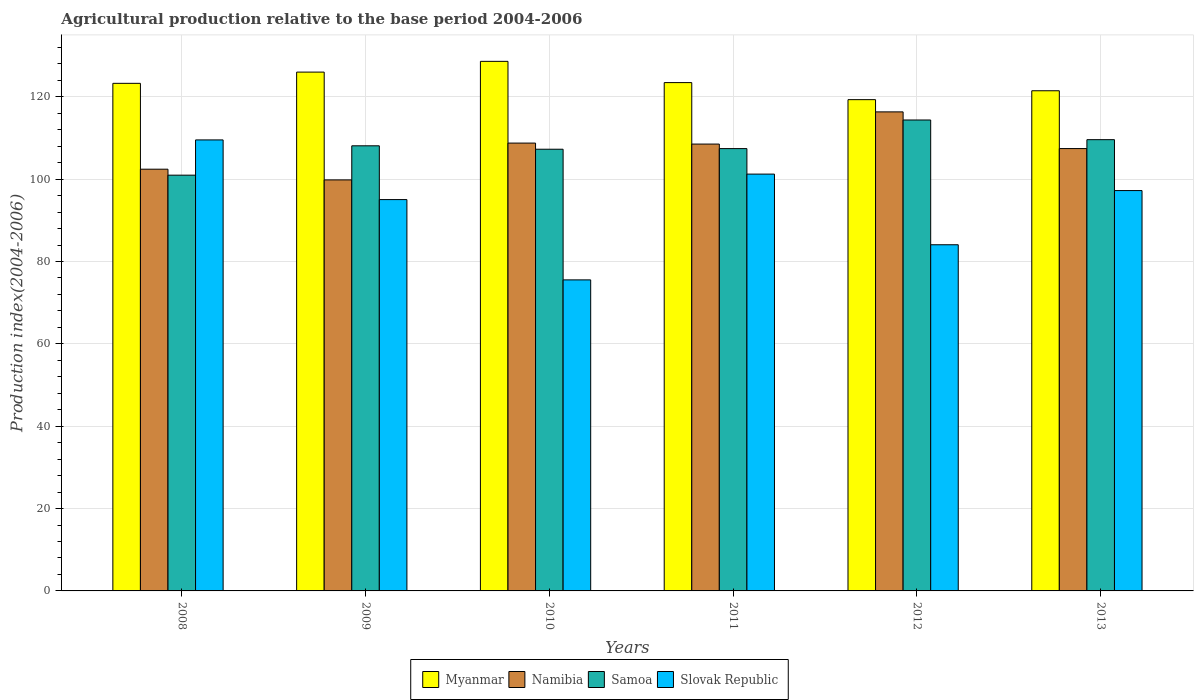How many different coloured bars are there?
Make the answer very short. 4. Are the number of bars per tick equal to the number of legend labels?
Your answer should be compact. Yes. What is the agricultural production index in Slovak Republic in 2013?
Your answer should be very brief. 97.23. Across all years, what is the maximum agricultural production index in Namibia?
Your response must be concise. 116.34. Across all years, what is the minimum agricultural production index in Samoa?
Give a very brief answer. 100.97. What is the total agricultural production index in Slovak Republic in the graph?
Make the answer very short. 562.64. What is the difference between the agricultural production index in Samoa in 2009 and that in 2012?
Offer a terse response. -6.27. What is the difference between the agricultural production index in Slovak Republic in 2008 and the agricultural production index in Samoa in 2010?
Offer a very short reply. 2.26. What is the average agricultural production index in Myanmar per year?
Give a very brief answer. 123.69. In the year 2009, what is the difference between the agricultural production index in Myanmar and agricultural production index in Namibia?
Keep it short and to the point. 26.18. What is the ratio of the agricultural production index in Slovak Republic in 2008 to that in 2013?
Your answer should be compact. 1.13. Is the agricultural production index in Myanmar in 2011 less than that in 2013?
Your answer should be compact. No. Is the difference between the agricultural production index in Myanmar in 2008 and 2011 greater than the difference between the agricultural production index in Namibia in 2008 and 2011?
Your answer should be compact. Yes. What is the difference between the highest and the second highest agricultural production index in Samoa?
Make the answer very short. 4.78. What is the difference between the highest and the lowest agricultural production index in Namibia?
Make the answer very short. 16.52. In how many years, is the agricultural production index in Samoa greater than the average agricultural production index in Samoa taken over all years?
Provide a short and direct response. 3. Is it the case that in every year, the sum of the agricultural production index in Samoa and agricultural production index in Slovak Republic is greater than the sum of agricultural production index in Myanmar and agricultural production index in Namibia?
Your answer should be compact. No. What does the 2nd bar from the left in 2008 represents?
Offer a very short reply. Namibia. What does the 2nd bar from the right in 2009 represents?
Ensure brevity in your answer.  Samoa. Is it the case that in every year, the sum of the agricultural production index in Myanmar and agricultural production index in Slovak Republic is greater than the agricultural production index in Samoa?
Offer a terse response. Yes. How many bars are there?
Offer a terse response. 24. How many years are there in the graph?
Offer a very short reply. 6. What is the difference between two consecutive major ticks on the Y-axis?
Offer a terse response. 20. Are the values on the major ticks of Y-axis written in scientific E-notation?
Keep it short and to the point. No. Where does the legend appear in the graph?
Provide a succinct answer. Bottom center. How are the legend labels stacked?
Provide a short and direct response. Horizontal. What is the title of the graph?
Provide a succinct answer. Agricultural production relative to the base period 2004-2006. Does "United States" appear as one of the legend labels in the graph?
Your response must be concise. No. What is the label or title of the Y-axis?
Your answer should be compact. Production index(2004-2006). What is the Production index(2004-2006) in Myanmar in 2008?
Keep it short and to the point. 123.27. What is the Production index(2004-2006) in Namibia in 2008?
Your answer should be very brief. 102.42. What is the Production index(2004-2006) in Samoa in 2008?
Provide a succinct answer. 100.97. What is the Production index(2004-2006) in Slovak Republic in 2008?
Your response must be concise. 109.53. What is the Production index(2004-2006) of Myanmar in 2009?
Your answer should be compact. 126. What is the Production index(2004-2006) of Namibia in 2009?
Provide a succinct answer. 99.82. What is the Production index(2004-2006) of Samoa in 2009?
Offer a terse response. 108.1. What is the Production index(2004-2006) of Slovak Republic in 2009?
Your answer should be very brief. 95.04. What is the Production index(2004-2006) of Myanmar in 2010?
Provide a succinct answer. 128.61. What is the Production index(2004-2006) of Namibia in 2010?
Offer a terse response. 108.76. What is the Production index(2004-2006) in Samoa in 2010?
Your answer should be very brief. 107.27. What is the Production index(2004-2006) in Slovak Republic in 2010?
Your response must be concise. 75.54. What is the Production index(2004-2006) of Myanmar in 2011?
Make the answer very short. 123.45. What is the Production index(2004-2006) of Namibia in 2011?
Provide a short and direct response. 108.52. What is the Production index(2004-2006) in Samoa in 2011?
Provide a succinct answer. 107.42. What is the Production index(2004-2006) of Slovak Republic in 2011?
Ensure brevity in your answer.  101.23. What is the Production index(2004-2006) in Myanmar in 2012?
Make the answer very short. 119.31. What is the Production index(2004-2006) in Namibia in 2012?
Ensure brevity in your answer.  116.34. What is the Production index(2004-2006) in Samoa in 2012?
Ensure brevity in your answer.  114.37. What is the Production index(2004-2006) of Slovak Republic in 2012?
Provide a short and direct response. 84.07. What is the Production index(2004-2006) in Myanmar in 2013?
Provide a succinct answer. 121.47. What is the Production index(2004-2006) of Namibia in 2013?
Your response must be concise. 107.43. What is the Production index(2004-2006) in Samoa in 2013?
Your answer should be compact. 109.59. What is the Production index(2004-2006) of Slovak Republic in 2013?
Your answer should be very brief. 97.23. Across all years, what is the maximum Production index(2004-2006) of Myanmar?
Give a very brief answer. 128.61. Across all years, what is the maximum Production index(2004-2006) of Namibia?
Your answer should be compact. 116.34. Across all years, what is the maximum Production index(2004-2006) of Samoa?
Your answer should be compact. 114.37. Across all years, what is the maximum Production index(2004-2006) of Slovak Republic?
Offer a very short reply. 109.53. Across all years, what is the minimum Production index(2004-2006) in Myanmar?
Your answer should be compact. 119.31. Across all years, what is the minimum Production index(2004-2006) in Namibia?
Your answer should be very brief. 99.82. Across all years, what is the minimum Production index(2004-2006) in Samoa?
Your answer should be compact. 100.97. Across all years, what is the minimum Production index(2004-2006) of Slovak Republic?
Your answer should be compact. 75.54. What is the total Production index(2004-2006) of Myanmar in the graph?
Provide a short and direct response. 742.11. What is the total Production index(2004-2006) of Namibia in the graph?
Your answer should be very brief. 643.29. What is the total Production index(2004-2006) in Samoa in the graph?
Offer a very short reply. 647.72. What is the total Production index(2004-2006) in Slovak Republic in the graph?
Give a very brief answer. 562.64. What is the difference between the Production index(2004-2006) in Myanmar in 2008 and that in 2009?
Keep it short and to the point. -2.73. What is the difference between the Production index(2004-2006) of Namibia in 2008 and that in 2009?
Your answer should be very brief. 2.6. What is the difference between the Production index(2004-2006) of Samoa in 2008 and that in 2009?
Ensure brevity in your answer.  -7.13. What is the difference between the Production index(2004-2006) of Slovak Republic in 2008 and that in 2009?
Provide a short and direct response. 14.49. What is the difference between the Production index(2004-2006) of Myanmar in 2008 and that in 2010?
Offer a terse response. -5.34. What is the difference between the Production index(2004-2006) in Namibia in 2008 and that in 2010?
Your response must be concise. -6.34. What is the difference between the Production index(2004-2006) in Samoa in 2008 and that in 2010?
Offer a very short reply. -6.3. What is the difference between the Production index(2004-2006) of Slovak Republic in 2008 and that in 2010?
Your response must be concise. 33.99. What is the difference between the Production index(2004-2006) of Myanmar in 2008 and that in 2011?
Give a very brief answer. -0.18. What is the difference between the Production index(2004-2006) of Samoa in 2008 and that in 2011?
Provide a succinct answer. -6.45. What is the difference between the Production index(2004-2006) of Slovak Republic in 2008 and that in 2011?
Provide a succinct answer. 8.3. What is the difference between the Production index(2004-2006) of Myanmar in 2008 and that in 2012?
Ensure brevity in your answer.  3.96. What is the difference between the Production index(2004-2006) of Namibia in 2008 and that in 2012?
Your response must be concise. -13.92. What is the difference between the Production index(2004-2006) in Samoa in 2008 and that in 2012?
Ensure brevity in your answer.  -13.4. What is the difference between the Production index(2004-2006) of Slovak Republic in 2008 and that in 2012?
Ensure brevity in your answer.  25.46. What is the difference between the Production index(2004-2006) of Namibia in 2008 and that in 2013?
Offer a very short reply. -5.01. What is the difference between the Production index(2004-2006) in Samoa in 2008 and that in 2013?
Give a very brief answer. -8.62. What is the difference between the Production index(2004-2006) in Myanmar in 2009 and that in 2010?
Your response must be concise. -2.61. What is the difference between the Production index(2004-2006) in Namibia in 2009 and that in 2010?
Make the answer very short. -8.94. What is the difference between the Production index(2004-2006) in Samoa in 2009 and that in 2010?
Provide a short and direct response. 0.83. What is the difference between the Production index(2004-2006) of Slovak Republic in 2009 and that in 2010?
Provide a succinct answer. 19.5. What is the difference between the Production index(2004-2006) of Myanmar in 2009 and that in 2011?
Make the answer very short. 2.55. What is the difference between the Production index(2004-2006) in Namibia in 2009 and that in 2011?
Offer a terse response. -8.7. What is the difference between the Production index(2004-2006) in Samoa in 2009 and that in 2011?
Make the answer very short. 0.68. What is the difference between the Production index(2004-2006) in Slovak Republic in 2009 and that in 2011?
Make the answer very short. -6.19. What is the difference between the Production index(2004-2006) of Myanmar in 2009 and that in 2012?
Give a very brief answer. 6.69. What is the difference between the Production index(2004-2006) in Namibia in 2009 and that in 2012?
Your answer should be compact. -16.52. What is the difference between the Production index(2004-2006) in Samoa in 2009 and that in 2012?
Offer a very short reply. -6.27. What is the difference between the Production index(2004-2006) of Slovak Republic in 2009 and that in 2012?
Give a very brief answer. 10.97. What is the difference between the Production index(2004-2006) in Myanmar in 2009 and that in 2013?
Keep it short and to the point. 4.53. What is the difference between the Production index(2004-2006) of Namibia in 2009 and that in 2013?
Make the answer very short. -7.61. What is the difference between the Production index(2004-2006) in Samoa in 2009 and that in 2013?
Offer a terse response. -1.49. What is the difference between the Production index(2004-2006) in Slovak Republic in 2009 and that in 2013?
Keep it short and to the point. -2.19. What is the difference between the Production index(2004-2006) of Myanmar in 2010 and that in 2011?
Your answer should be very brief. 5.16. What is the difference between the Production index(2004-2006) of Namibia in 2010 and that in 2011?
Your answer should be very brief. 0.24. What is the difference between the Production index(2004-2006) of Samoa in 2010 and that in 2011?
Ensure brevity in your answer.  -0.15. What is the difference between the Production index(2004-2006) of Slovak Republic in 2010 and that in 2011?
Ensure brevity in your answer.  -25.69. What is the difference between the Production index(2004-2006) in Myanmar in 2010 and that in 2012?
Provide a succinct answer. 9.3. What is the difference between the Production index(2004-2006) in Namibia in 2010 and that in 2012?
Provide a succinct answer. -7.58. What is the difference between the Production index(2004-2006) of Samoa in 2010 and that in 2012?
Provide a short and direct response. -7.1. What is the difference between the Production index(2004-2006) of Slovak Republic in 2010 and that in 2012?
Your answer should be compact. -8.53. What is the difference between the Production index(2004-2006) of Myanmar in 2010 and that in 2013?
Your response must be concise. 7.14. What is the difference between the Production index(2004-2006) of Namibia in 2010 and that in 2013?
Offer a terse response. 1.33. What is the difference between the Production index(2004-2006) of Samoa in 2010 and that in 2013?
Offer a very short reply. -2.32. What is the difference between the Production index(2004-2006) of Slovak Republic in 2010 and that in 2013?
Provide a succinct answer. -21.69. What is the difference between the Production index(2004-2006) of Myanmar in 2011 and that in 2012?
Ensure brevity in your answer.  4.14. What is the difference between the Production index(2004-2006) of Namibia in 2011 and that in 2012?
Your response must be concise. -7.82. What is the difference between the Production index(2004-2006) in Samoa in 2011 and that in 2012?
Ensure brevity in your answer.  -6.95. What is the difference between the Production index(2004-2006) of Slovak Republic in 2011 and that in 2012?
Offer a very short reply. 17.16. What is the difference between the Production index(2004-2006) in Myanmar in 2011 and that in 2013?
Your answer should be very brief. 1.98. What is the difference between the Production index(2004-2006) in Namibia in 2011 and that in 2013?
Your response must be concise. 1.09. What is the difference between the Production index(2004-2006) of Samoa in 2011 and that in 2013?
Provide a short and direct response. -2.17. What is the difference between the Production index(2004-2006) of Slovak Republic in 2011 and that in 2013?
Provide a short and direct response. 4. What is the difference between the Production index(2004-2006) of Myanmar in 2012 and that in 2013?
Offer a terse response. -2.16. What is the difference between the Production index(2004-2006) in Namibia in 2012 and that in 2013?
Provide a succinct answer. 8.91. What is the difference between the Production index(2004-2006) of Samoa in 2012 and that in 2013?
Ensure brevity in your answer.  4.78. What is the difference between the Production index(2004-2006) of Slovak Republic in 2012 and that in 2013?
Give a very brief answer. -13.16. What is the difference between the Production index(2004-2006) of Myanmar in 2008 and the Production index(2004-2006) of Namibia in 2009?
Provide a short and direct response. 23.45. What is the difference between the Production index(2004-2006) in Myanmar in 2008 and the Production index(2004-2006) in Samoa in 2009?
Your response must be concise. 15.17. What is the difference between the Production index(2004-2006) of Myanmar in 2008 and the Production index(2004-2006) of Slovak Republic in 2009?
Provide a succinct answer. 28.23. What is the difference between the Production index(2004-2006) in Namibia in 2008 and the Production index(2004-2006) in Samoa in 2009?
Offer a terse response. -5.68. What is the difference between the Production index(2004-2006) of Namibia in 2008 and the Production index(2004-2006) of Slovak Republic in 2009?
Your response must be concise. 7.38. What is the difference between the Production index(2004-2006) in Samoa in 2008 and the Production index(2004-2006) in Slovak Republic in 2009?
Make the answer very short. 5.93. What is the difference between the Production index(2004-2006) in Myanmar in 2008 and the Production index(2004-2006) in Namibia in 2010?
Offer a terse response. 14.51. What is the difference between the Production index(2004-2006) in Myanmar in 2008 and the Production index(2004-2006) in Slovak Republic in 2010?
Your answer should be compact. 47.73. What is the difference between the Production index(2004-2006) of Namibia in 2008 and the Production index(2004-2006) of Samoa in 2010?
Give a very brief answer. -4.85. What is the difference between the Production index(2004-2006) of Namibia in 2008 and the Production index(2004-2006) of Slovak Republic in 2010?
Make the answer very short. 26.88. What is the difference between the Production index(2004-2006) in Samoa in 2008 and the Production index(2004-2006) in Slovak Republic in 2010?
Give a very brief answer. 25.43. What is the difference between the Production index(2004-2006) in Myanmar in 2008 and the Production index(2004-2006) in Namibia in 2011?
Your response must be concise. 14.75. What is the difference between the Production index(2004-2006) in Myanmar in 2008 and the Production index(2004-2006) in Samoa in 2011?
Ensure brevity in your answer.  15.85. What is the difference between the Production index(2004-2006) in Myanmar in 2008 and the Production index(2004-2006) in Slovak Republic in 2011?
Keep it short and to the point. 22.04. What is the difference between the Production index(2004-2006) in Namibia in 2008 and the Production index(2004-2006) in Slovak Republic in 2011?
Keep it short and to the point. 1.19. What is the difference between the Production index(2004-2006) in Samoa in 2008 and the Production index(2004-2006) in Slovak Republic in 2011?
Your answer should be very brief. -0.26. What is the difference between the Production index(2004-2006) in Myanmar in 2008 and the Production index(2004-2006) in Namibia in 2012?
Your response must be concise. 6.93. What is the difference between the Production index(2004-2006) in Myanmar in 2008 and the Production index(2004-2006) in Slovak Republic in 2012?
Your answer should be very brief. 39.2. What is the difference between the Production index(2004-2006) in Namibia in 2008 and the Production index(2004-2006) in Samoa in 2012?
Provide a short and direct response. -11.95. What is the difference between the Production index(2004-2006) in Namibia in 2008 and the Production index(2004-2006) in Slovak Republic in 2012?
Give a very brief answer. 18.35. What is the difference between the Production index(2004-2006) in Samoa in 2008 and the Production index(2004-2006) in Slovak Republic in 2012?
Keep it short and to the point. 16.9. What is the difference between the Production index(2004-2006) of Myanmar in 2008 and the Production index(2004-2006) of Namibia in 2013?
Your answer should be compact. 15.84. What is the difference between the Production index(2004-2006) in Myanmar in 2008 and the Production index(2004-2006) in Samoa in 2013?
Your answer should be compact. 13.68. What is the difference between the Production index(2004-2006) of Myanmar in 2008 and the Production index(2004-2006) of Slovak Republic in 2013?
Offer a terse response. 26.04. What is the difference between the Production index(2004-2006) of Namibia in 2008 and the Production index(2004-2006) of Samoa in 2013?
Your response must be concise. -7.17. What is the difference between the Production index(2004-2006) of Namibia in 2008 and the Production index(2004-2006) of Slovak Republic in 2013?
Ensure brevity in your answer.  5.19. What is the difference between the Production index(2004-2006) in Samoa in 2008 and the Production index(2004-2006) in Slovak Republic in 2013?
Offer a terse response. 3.74. What is the difference between the Production index(2004-2006) of Myanmar in 2009 and the Production index(2004-2006) of Namibia in 2010?
Provide a succinct answer. 17.24. What is the difference between the Production index(2004-2006) of Myanmar in 2009 and the Production index(2004-2006) of Samoa in 2010?
Provide a short and direct response. 18.73. What is the difference between the Production index(2004-2006) in Myanmar in 2009 and the Production index(2004-2006) in Slovak Republic in 2010?
Offer a very short reply. 50.46. What is the difference between the Production index(2004-2006) in Namibia in 2009 and the Production index(2004-2006) in Samoa in 2010?
Your answer should be very brief. -7.45. What is the difference between the Production index(2004-2006) of Namibia in 2009 and the Production index(2004-2006) of Slovak Republic in 2010?
Make the answer very short. 24.28. What is the difference between the Production index(2004-2006) of Samoa in 2009 and the Production index(2004-2006) of Slovak Republic in 2010?
Offer a terse response. 32.56. What is the difference between the Production index(2004-2006) of Myanmar in 2009 and the Production index(2004-2006) of Namibia in 2011?
Provide a short and direct response. 17.48. What is the difference between the Production index(2004-2006) in Myanmar in 2009 and the Production index(2004-2006) in Samoa in 2011?
Offer a terse response. 18.58. What is the difference between the Production index(2004-2006) of Myanmar in 2009 and the Production index(2004-2006) of Slovak Republic in 2011?
Provide a short and direct response. 24.77. What is the difference between the Production index(2004-2006) of Namibia in 2009 and the Production index(2004-2006) of Samoa in 2011?
Keep it short and to the point. -7.6. What is the difference between the Production index(2004-2006) of Namibia in 2009 and the Production index(2004-2006) of Slovak Republic in 2011?
Make the answer very short. -1.41. What is the difference between the Production index(2004-2006) in Samoa in 2009 and the Production index(2004-2006) in Slovak Republic in 2011?
Keep it short and to the point. 6.87. What is the difference between the Production index(2004-2006) of Myanmar in 2009 and the Production index(2004-2006) of Namibia in 2012?
Your response must be concise. 9.66. What is the difference between the Production index(2004-2006) in Myanmar in 2009 and the Production index(2004-2006) in Samoa in 2012?
Offer a terse response. 11.63. What is the difference between the Production index(2004-2006) of Myanmar in 2009 and the Production index(2004-2006) of Slovak Republic in 2012?
Keep it short and to the point. 41.93. What is the difference between the Production index(2004-2006) in Namibia in 2009 and the Production index(2004-2006) in Samoa in 2012?
Your answer should be compact. -14.55. What is the difference between the Production index(2004-2006) in Namibia in 2009 and the Production index(2004-2006) in Slovak Republic in 2012?
Provide a short and direct response. 15.75. What is the difference between the Production index(2004-2006) of Samoa in 2009 and the Production index(2004-2006) of Slovak Republic in 2012?
Your response must be concise. 24.03. What is the difference between the Production index(2004-2006) of Myanmar in 2009 and the Production index(2004-2006) of Namibia in 2013?
Provide a short and direct response. 18.57. What is the difference between the Production index(2004-2006) of Myanmar in 2009 and the Production index(2004-2006) of Samoa in 2013?
Provide a short and direct response. 16.41. What is the difference between the Production index(2004-2006) of Myanmar in 2009 and the Production index(2004-2006) of Slovak Republic in 2013?
Your answer should be very brief. 28.77. What is the difference between the Production index(2004-2006) in Namibia in 2009 and the Production index(2004-2006) in Samoa in 2013?
Your answer should be compact. -9.77. What is the difference between the Production index(2004-2006) of Namibia in 2009 and the Production index(2004-2006) of Slovak Republic in 2013?
Provide a succinct answer. 2.59. What is the difference between the Production index(2004-2006) in Samoa in 2009 and the Production index(2004-2006) in Slovak Republic in 2013?
Keep it short and to the point. 10.87. What is the difference between the Production index(2004-2006) of Myanmar in 2010 and the Production index(2004-2006) of Namibia in 2011?
Keep it short and to the point. 20.09. What is the difference between the Production index(2004-2006) of Myanmar in 2010 and the Production index(2004-2006) of Samoa in 2011?
Provide a succinct answer. 21.19. What is the difference between the Production index(2004-2006) in Myanmar in 2010 and the Production index(2004-2006) in Slovak Republic in 2011?
Offer a very short reply. 27.38. What is the difference between the Production index(2004-2006) in Namibia in 2010 and the Production index(2004-2006) in Samoa in 2011?
Give a very brief answer. 1.34. What is the difference between the Production index(2004-2006) in Namibia in 2010 and the Production index(2004-2006) in Slovak Republic in 2011?
Your answer should be very brief. 7.53. What is the difference between the Production index(2004-2006) of Samoa in 2010 and the Production index(2004-2006) of Slovak Republic in 2011?
Your response must be concise. 6.04. What is the difference between the Production index(2004-2006) in Myanmar in 2010 and the Production index(2004-2006) in Namibia in 2012?
Give a very brief answer. 12.27. What is the difference between the Production index(2004-2006) of Myanmar in 2010 and the Production index(2004-2006) of Samoa in 2012?
Give a very brief answer. 14.24. What is the difference between the Production index(2004-2006) in Myanmar in 2010 and the Production index(2004-2006) in Slovak Republic in 2012?
Provide a short and direct response. 44.54. What is the difference between the Production index(2004-2006) in Namibia in 2010 and the Production index(2004-2006) in Samoa in 2012?
Provide a short and direct response. -5.61. What is the difference between the Production index(2004-2006) of Namibia in 2010 and the Production index(2004-2006) of Slovak Republic in 2012?
Keep it short and to the point. 24.69. What is the difference between the Production index(2004-2006) of Samoa in 2010 and the Production index(2004-2006) of Slovak Republic in 2012?
Keep it short and to the point. 23.2. What is the difference between the Production index(2004-2006) of Myanmar in 2010 and the Production index(2004-2006) of Namibia in 2013?
Your answer should be compact. 21.18. What is the difference between the Production index(2004-2006) of Myanmar in 2010 and the Production index(2004-2006) of Samoa in 2013?
Provide a short and direct response. 19.02. What is the difference between the Production index(2004-2006) of Myanmar in 2010 and the Production index(2004-2006) of Slovak Republic in 2013?
Ensure brevity in your answer.  31.38. What is the difference between the Production index(2004-2006) in Namibia in 2010 and the Production index(2004-2006) in Samoa in 2013?
Your answer should be compact. -0.83. What is the difference between the Production index(2004-2006) of Namibia in 2010 and the Production index(2004-2006) of Slovak Republic in 2013?
Give a very brief answer. 11.53. What is the difference between the Production index(2004-2006) of Samoa in 2010 and the Production index(2004-2006) of Slovak Republic in 2013?
Provide a short and direct response. 10.04. What is the difference between the Production index(2004-2006) in Myanmar in 2011 and the Production index(2004-2006) in Namibia in 2012?
Offer a very short reply. 7.11. What is the difference between the Production index(2004-2006) of Myanmar in 2011 and the Production index(2004-2006) of Samoa in 2012?
Provide a succinct answer. 9.08. What is the difference between the Production index(2004-2006) of Myanmar in 2011 and the Production index(2004-2006) of Slovak Republic in 2012?
Your answer should be very brief. 39.38. What is the difference between the Production index(2004-2006) in Namibia in 2011 and the Production index(2004-2006) in Samoa in 2012?
Provide a short and direct response. -5.85. What is the difference between the Production index(2004-2006) of Namibia in 2011 and the Production index(2004-2006) of Slovak Republic in 2012?
Give a very brief answer. 24.45. What is the difference between the Production index(2004-2006) of Samoa in 2011 and the Production index(2004-2006) of Slovak Republic in 2012?
Make the answer very short. 23.35. What is the difference between the Production index(2004-2006) in Myanmar in 2011 and the Production index(2004-2006) in Namibia in 2013?
Provide a succinct answer. 16.02. What is the difference between the Production index(2004-2006) of Myanmar in 2011 and the Production index(2004-2006) of Samoa in 2013?
Your answer should be very brief. 13.86. What is the difference between the Production index(2004-2006) of Myanmar in 2011 and the Production index(2004-2006) of Slovak Republic in 2013?
Your answer should be compact. 26.22. What is the difference between the Production index(2004-2006) in Namibia in 2011 and the Production index(2004-2006) in Samoa in 2013?
Provide a succinct answer. -1.07. What is the difference between the Production index(2004-2006) of Namibia in 2011 and the Production index(2004-2006) of Slovak Republic in 2013?
Offer a very short reply. 11.29. What is the difference between the Production index(2004-2006) of Samoa in 2011 and the Production index(2004-2006) of Slovak Republic in 2013?
Ensure brevity in your answer.  10.19. What is the difference between the Production index(2004-2006) of Myanmar in 2012 and the Production index(2004-2006) of Namibia in 2013?
Your answer should be compact. 11.88. What is the difference between the Production index(2004-2006) in Myanmar in 2012 and the Production index(2004-2006) in Samoa in 2013?
Your response must be concise. 9.72. What is the difference between the Production index(2004-2006) of Myanmar in 2012 and the Production index(2004-2006) of Slovak Republic in 2013?
Give a very brief answer. 22.08. What is the difference between the Production index(2004-2006) in Namibia in 2012 and the Production index(2004-2006) in Samoa in 2013?
Offer a terse response. 6.75. What is the difference between the Production index(2004-2006) of Namibia in 2012 and the Production index(2004-2006) of Slovak Republic in 2013?
Make the answer very short. 19.11. What is the difference between the Production index(2004-2006) of Samoa in 2012 and the Production index(2004-2006) of Slovak Republic in 2013?
Keep it short and to the point. 17.14. What is the average Production index(2004-2006) in Myanmar per year?
Make the answer very short. 123.69. What is the average Production index(2004-2006) in Namibia per year?
Provide a succinct answer. 107.22. What is the average Production index(2004-2006) in Samoa per year?
Provide a succinct answer. 107.95. What is the average Production index(2004-2006) in Slovak Republic per year?
Ensure brevity in your answer.  93.77. In the year 2008, what is the difference between the Production index(2004-2006) of Myanmar and Production index(2004-2006) of Namibia?
Your answer should be very brief. 20.85. In the year 2008, what is the difference between the Production index(2004-2006) in Myanmar and Production index(2004-2006) in Samoa?
Provide a succinct answer. 22.3. In the year 2008, what is the difference between the Production index(2004-2006) in Myanmar and Production index(2004-2006) in Slovak Republic?
Make the answer very short. 13.74. In the year 2008, what is the difference between the Production index(2004-2006) in Namibia and Production index(2004-2006) in Samoa?
Make the answer very short. 1.45. In the year 2008, what is the difference between the Production index(2004-2006) in Namibia and Production index(2004-2006) in Slovak Republic?
Give a very brief answer. -7.11. In the year 2008, what is the difference between the Production index(2004-2006) in Samoa and Production index(2004-2006) in Slovak Republic?
Your answer should be compact. -8.56. In the year 2009, what is the difference between the Production index(2004-2006) of Myanmar and Production index(2004-2006) of Namibia?
Your response must be concise. 26.18. In the year 2009, what is the difference between the Production index(2004-2006) in Myanmar and Production index(2004-2006) in Slovak Republic?
Your response must be concise. 30.96. In the year 2009, what is the difference between the Production index(2004-2006) in Namibia and Production index(2004-2006) in Samoa?
Offer a very short reply. -8.28. In the year 2009, what is the difference between the Production index(2004-2006) in Namibia and Production index(2004-2006) in Slovak Republic?
Your answer should be very brief. 4.78. In the year 2009, what is the difference between the Production index(2004-2006) of Samoa and Production index(2004-2006) of Slovak Republic?
Offer a very short reply. 13.06. In the year 2010, what is the difference between the Production index(2004-2006) of Myanmar and Production index(2004-2006) of Namibia?
Provide a succinct answer. 19.85. In the year 2010, what is the difference between the Production index(2004-2006) in Myanmar and Production index(2004-2006) in Samoa?
Offer a very short reply. 21.34. In the year 2010, what is the difference between the Production index(2004-2006) in Myanmar and Production index(2004-2006) in Slovak Republic?
Give a very brief answer. 53.07. In the year 2010, what is the difference between the Production index(2004-2006) in Namibia and Production index(2004-2006) in Samoa?
Offer a terse response. 1.49. In the year 2010, what is the difference between the Production index(2004-2006) in Namibia and Production index(2004-2006) in Slovak Republic?
Keep it short and to the point. 33.22. In the year 2010, what is the difference between the Production index(2004-2006) in Samoa and Production index(2004-2006) in Slovak Republic?
Make the answer very short. 31.73. In the year 2011, what is the difference between the Production index(2004-2006) of Myanmar and Production index(2004-2006) of Namibia?
Keep it short and to the point. 14.93. In the year 2011, what is the difference between the Production index(2004-2006) in Myanmar and Production index(2004-2006) in Samoa?
Keep it short and to the point. 16.03. In the year 2011, what is the difference between the Production index(2004-2006) of Myanmar and Production index(2004-2006) of Slovak Republic?
Ensure brevity in your answer.  22.22. In the year 2011, what is the difference between the Production index(2004-2006) in Namibia and Production index(2004-2006) in Samoa?
Provide a succinct answer. 1.1. In the year 2011, what is the difference between the Production index(2004-2006) in Namibia and Production index(2004-2006) in Slovak Republic?
Make the answer very short. 7.29. In the year 2011, what is the difference between the Production index(2004-2006) in Samoa and Production index(2004-2006) in Slovak Republic?
Your answer should be compact. 6.19. In the year 2012, what is the difference between the Production index(2004-2006) in Myanmar and Production index(2004-2006) in Namibia?
Offer a terse response. 2.97. In the year 2012, what is the difference between the Production index(2004-2006) of Myanmar and Production index(2004-2006) of Samoa?
Your answer should be very brief. 4.94. In the year 2012, what is the difference between the Production index(2004-2006) of Myanmar and Production index(2004-2006) of Slovak Republic?
Offer a terse response. 35.24. In the year 2012, what is the difference between the Production index(2004-2006) of Namibia and Production index(2004-2006) of Samoa?
Your response must be concise. 1.97. In the year 2012, what is the difference between the Production index(2004-2006) of Namibia and Production index(2004-2006) of Slovak Republic?
Provide a short and direct response. 32.27. In the year 2012, what is the difference between the Production index(2004-2006) in Samoa and Production index(2004-2006) in Slovak Republic?
Keep it short and to the point. 30.3. In the year 2013, what is the difference between the Production index(2004-2006) of Myanmar and Production index(2004-2006) of Namibia?
Your answer should be compact. 14.04. In the year 2013, what is the difference between the Production index(2004-2006) in Myanmar and Production index(2004-2006) in Samoa?
Keep it short and to the point. 11.88. In the year 2013, what is the difference between the Production index(2004-2006) of Myanmar and Production index(2004-2006) of Slovak Republic?
Your answer should be compact. 24.24. In the year 2013, what is the difference between the Production index(2004-2006) of Namibia and Production index(2004-2006) of Samoa?
Provide a succinct answer. -2.16. In the year 2013, what is the difference between the Production index(2004-2006) in Samoa and Production index(2004-2006) in Slovak Republic?
Your answer should be compact. 12.36. What is the ratio of the Production index(2004-2006) of Myanmar in 2008 to that in 2009?
Offer a terse response. 0.98. What is the ratio of the Production index(2004-2006) in Namibia in 2008 to that in 2009?
Make the answer very short. 1.03. What is the ratio of the Production index(2004-2006) in Samoa in 2008 to that in 2009?
Offer a terse response. 0.93. What is the ratio of the Production index(2004-2006) of Slovak Republic in 2008 to that in 2009?
Your answer should be very brief. 1.15. What is the ratio of the Production index(2004-2006) in Myanmar in 2008 to that in 2010?
Provide a succinct answer. 0.96. What is the ratio of the Production index(2004-2006) in Namibia in 2008 to that in 2010?
Ensure brevity in your answer.  0.94. What is the ratio of the Production index(2004-2006) in Samoa in 2008 to that in 2010?
Your answer should be compact. 0.94. What is the ratio of the Production index(2004-2006) in Slovak Republic in 2008 to that in 2010?
Offer a terse response. 1.45. What is the ratio of the Production index(2004-2006) in Namibia in 2008 to that in 2011?
Provide a short and direct response. 0.94. What is the ratio of the Production index(2004-2006) in Slovak Republic in 2008 to that in 2011?
Your response must be concise. 1.08. What is the ratio of the Production index(2004-2006) of Myanmar in 2008 to that in 2012?
Your answer should be very brief. 1.03. What is the ratio of the Production index(2004-2006) of Namibia in 2008 to that in 2012?
Make the answer very short. 0.88. What is the ratio of the Production index(2004-2006) of Samoa in 2008 to that in 2012?
Ensure brevity in your answer.  0.88. What is the ratio of the Production index(2004-2006) in Slovak Republic in 2008 to that in 2012?
Your answer should be compact. 1.3. What is the ratio of the Production index(2004-2006) of Myanmar in 2008 to that in 2013?
Give a very brief answer. 1.01. What is the ratio of the Production index(2004-2006) of Namibia in 2008 to that in 2013?
Your answer should be very brief. 0.95. What is the ratio of the Production index(2004-2006) of Samoa in 2008 to that in 2013?
Keep it short and to the point. 0.92. What is the ratio of the Production index(2004-2006) of Slovak Republic in 2008 to that in 2013?
Keep it short and to the point. 1.13. What is the ratio of the Production index(2004-2006) of Myanmar in 2009 to that in 2010?
Your response must be concise. 0.98. What is the ratio of the Production index(2004-2006) in Namibia in 2009 to that in 2010?
Provide a short and direct response. 0.92. What is the ratio of the Production index(2004-2006) in Samoa in 2009 to that in 2010?
Offer a terse response. 1.01. What is the ratio of the Production index(2004-2006) in Slovak Republic in 2009 to that in 2010?
Keep it short and to the point. 1.26. What is the ratio of the Production index(2004-2006) in Myanmar in 2009 to that in 2011?
Make the answer very short. 1.02. What is the ratio of the Production index(2004-2006) in Namibia in 2009 to that in 2011?
Offer a very short reply. 0.92. What is the ratio of the Production index(2004-2006) of Samoa in 2009 to that in 2011?
Provide a succinct answer. 1.01. What is the ratio of the Production index(2004-2006) in Slovak Republic in 2009 to that in 2011?
Keep it short and to the point. 0.94. What is the ratio of the Production index(2004-2006) in Myanmar in 2009 to that in 2012?
Your answer should be very brief. 1.06. What is the ratio of the Production index(2004-2006) in Namibia in 2009 to that in 2012?
Offer a terse response. 0.86. What is the ratio of the Production index(2004-2006) in Samoa in 2009 to that in 2012?
Offer a very short reply. 0.95. What is the ratio of the Production index(2004-2006) of Slovak Republic in 2009 to that in 2012?
Offer a very short reply. 1.13. What is the ratio of the Production index(2004-2006) of Myanmar in 2009 to that in 2013?
Provide a succinct answer. 1.04. What is the ratio of the Production index(2004-2006) in Namibia in 2009 to that in 2013?
Ensure brevity in your answer.  0.93. What is the ratio of the Production index(2004-2006) of Samoa in 2009 to that in 2013?
Your answer should be compact. 0.99. What is the ratio of the Production index(2004-2006) of Slovak Republic in 2009 to that in 2013?
Offer a very short reply. 0.98. What is the ratio of the Production index(2004-2006) in Myanmar in 2010 to that in 2011?
Your answer should be compact. 1.04. What is the ratio of the Production index(2004-2006) in Namibia in 2010 to that in 2011?
Your answer should be very brief. 1. What is the ratio of the Production index(2004-2006) in Slovak Republic in 2010 to that in 2011?
Give a very brief answer. 0.75. What is the ratio of the Production index(2004-2006) of Myanmar in 2010 to that in 2012?
Provide a succinct answer. 1.08. What is the ratio of the Production index(2004-2006) in Namibia in 2010 to that in 2012?
Ensure brevity in your answer.  0.93. What is the ratio of the Production index(2004-2006) in Samoa in 2010 to that in 2012?
Your response must be concise. 0.94. What is the ratio of the Production index(2004-2006) in Slovak Republic in 2010 to that in 2012?
Keep it short and to the point. 0.9. What is the ratio of the Production index(2004-2006) in Myanmar in 2010 to that in 2013?
Offer a terse response. 1.06. What is the ratio of the Production index(2004-2006) of Namibia in 2010 to that in 2013?
Your response must be concise. 1.01. What is the ratio of the Production index(2004-2006) in Samoa in 2010 to that in 2013?
Ensure brevity in your answer.  0.98. What is the ratio of the Production index(2004-2006) of Slovak Republic in 2010 to that in 2013?
Keep it short and to the point. 0.78. What is the ratio of the Production index(2004-2006) in Myanmar in 2011 to that in 2012?
Provide a succinct answer. 1.03. What is the ratio of the Production index(2004-2006) of Namibia in 2011 to that in 2012?
Make the answer very short. 0.93. What is the ratio of the Production index(2004-2006) in Samoa in 2011 to that in 2012?
Provide a succinct answer. 0.94. What is the ratio of the Production index(2004-2006) of Slovak Republic in 2011 to that in 2012?
Your response must be concise. 1.2. What is the ratio of the Production index(2004-2006) of Myanmar in 2011 to that in 2013?
Ensure brevity in your answer.  1.02. What is the ratio of the Production index(2004-2006) in Samoa in 2011 to that in 2013?
Your answer should be compact. 0.98. What is the ratio of the Production index(2004-2006) of Slovak Republic in 2011 to that in 2013?
Your response must be concise. 1.04. What is the ratio of the Production index(2004-2006) in Myanmar in 2012 to that in 2013?
Provide a succinct answer. 0.98. What is the ratio of the Production index(2004-2006) in Namibia in 2012 to that in 2013?
Provide a short and direct response. 1.08. What is the ratio of the Production index(2004-2006) of Samoa in 2012 to that in 2013?
Keep it short and to the point. 1.04. What is the ratio of the Production index(2004-2006) in Slovak Republic in 2012 to that in 2013?
Offer a terse response. 0.86. What is the difference between the highest and the second highest Production index(2004-2006) in Myanmar?
Make the answer very short. 2.61. What is the difference between the highest and the second highest Production index(2004-2006) in Namibia?
Ensure brevity in your answer.  7.58. What is the difference between the highest and the second highest Production index(2004-2006) of Samoa?
Ensure brevity in your answer.  4.78. What is the difference between the highest and the second highest Production index(2004-2006) in Slovak Republic?
Offer a very short reply. 8.3. What is the difference between the highest and the lowest Production index(2004-2006) of Myanmar?
Provide a succinct answer. 9.3. What is the difference between the highest and the lowest Production index(2004-2006) in Namibia?
Your response must be concise. 16.52. What is the difference between the highest and the lowest Production index(2004-2006) in Slovak Republic?
Provide a short and direct response. 33.99. 